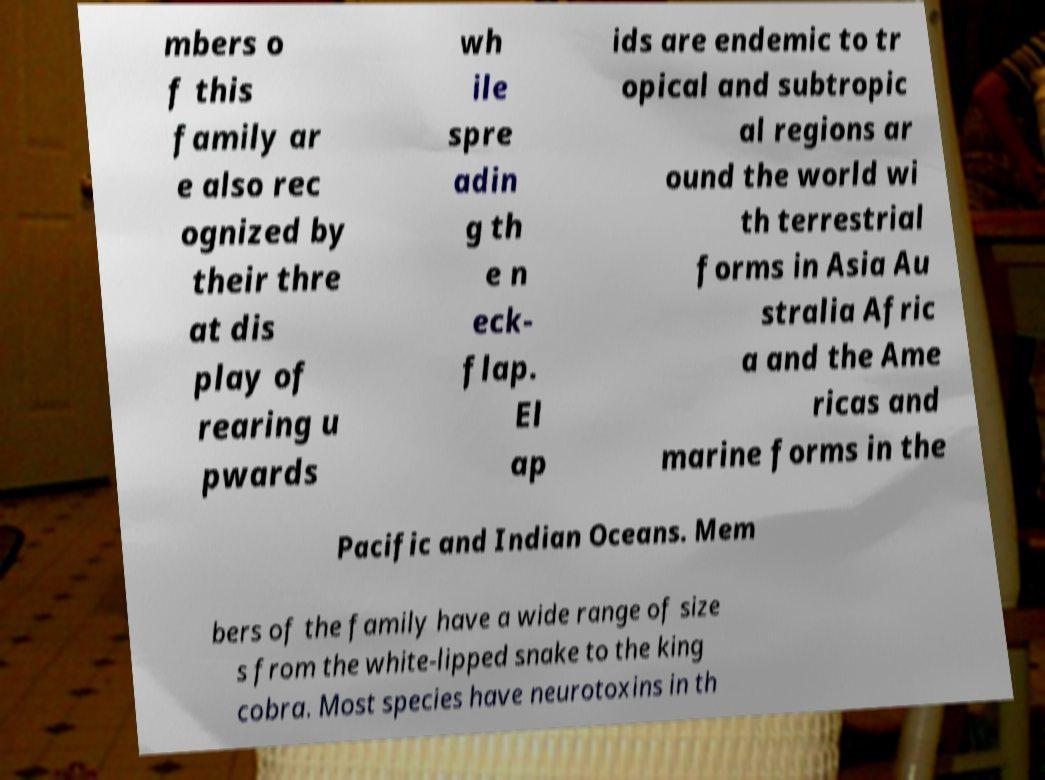Can you accurately transcribe the text from the provided image for me? mbers o f this family ar e also rec ognized by their thre at dis play of rearing u pwards wh ile spre adin g th e n eck- flap. El ap ids are endemic to tr opical and subtropic al regions ar ound the world wi th terrestrial forms in Asia Au stralia Afric a and the Ame ricas and marine forms in the Pacific and Indian Oceans. Mem bers of the family have a wide range of size s from the white-lipped snake to the king cobra. Most species have neurotoxins in th 